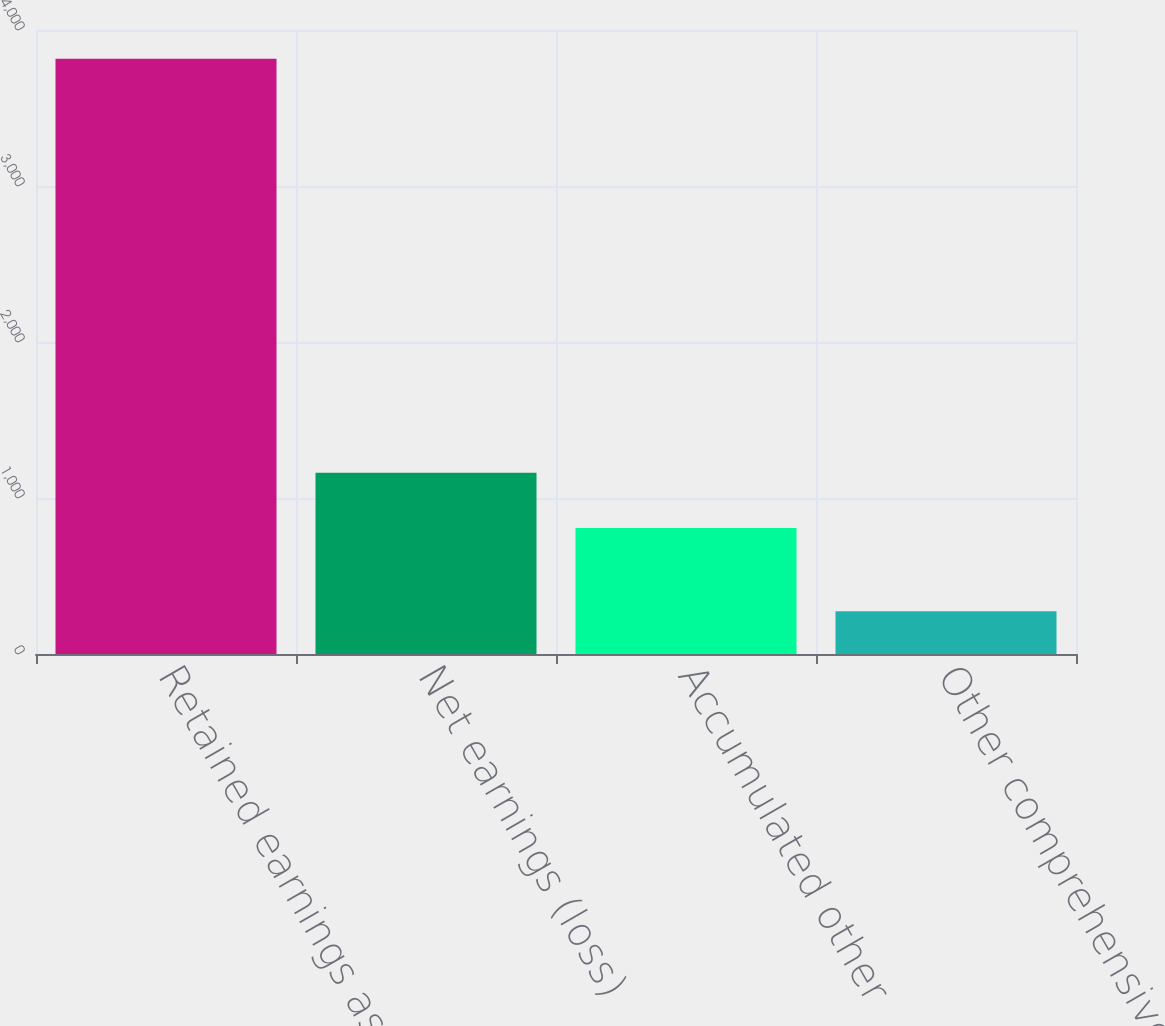<chart> <loc_0><loc_0><loc_500><loc_500><bar_chart><fcel>Retained earnings as of the<fcel>Net earnings (loss)<fcel>Accumulated other<fcel>Other comprehensive income<nl><fcel>3815<fcel>1162.1<fcel>808<fcel>274<nl></chart> 